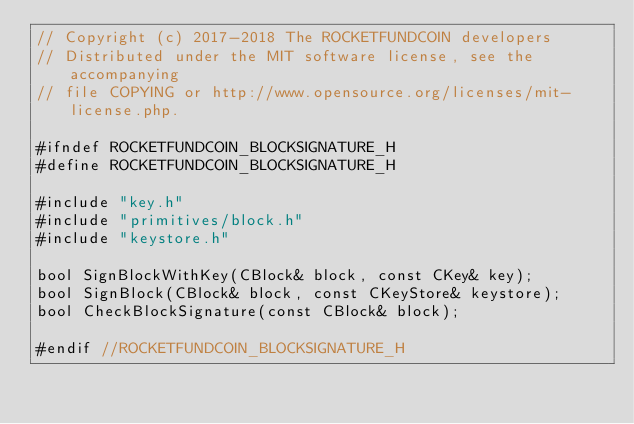<code> <loc_0><loc_0><loc_500><loc_500><_C_>// Copyright (c) 2017-2018 The ROCKETFUNDCOIN developers
// Distributed under the MIT software license, see the accompanying
// file COPYING or http://www.opensource.org/licenses/mit-license.php.

#ifndef ROCKETFUNDCOIN_BLOCKSIGNATURE_H
#define ROCKETFUNDCOIN_BLOCKSIGNATURE_H

#include "key.h"
#include "primitives/block.h"
#include "keystore.h"

bool SignBlockWithKey(CBlock& block, const CKey& key);
bool SignBlock(CBlock& block, const CKeyStore& keystore);
bool CheckBlockSignature(const CBlock& block);

#endif //ROCKETFUNDCOIN_BLOCKSIGNATURE_H
</code> 